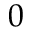Convert formula to latex. <formula><loc_0><loc_0><loc_500><loc_500>0</formula> 